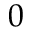Convert formula to latex. <formula><loc_0><loc_0><loc_500><loc_500>0</formula> 